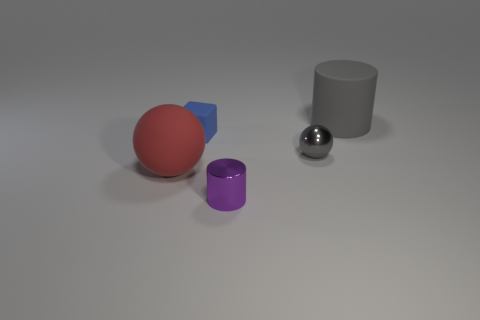What size is the red sphere that is made of the same material as the large gray thing?
Offer a terse response. Large. Are there more things than tiny green metallic cylinders?
Ensure brevity in your answer.  Yes. What is the material of the blue thing that is the same size as the gray sphere?
Ensure brevity in your answer.  Rubber. Does the cylinder on the right side of the purple metal cylinder have the same size as the small metallic cylinder?
Keep it short and to the point. No. How many blocks are either gray metal things or large gray rubber things?
Provide a succinct answer. 0. There is a big thing to the left of the metal sphere; what material is it?
Ensure brevity in your answer.  Rubber. Is the number of tiny metallic cylinders less than the number of large purple matte balls?
Your response must be concise. No. There is a thing that is both in front of the cube and on the left side of the purple metallic cylinder; what is its size?
Your answer should be very brief. Large. There is a shiny ball on the right side of the cylinder that is in front of the big matte object that is behind the gray metal object; what size is it?
Ensure brevity in your answer.  Small. How many other things are the same color as the large matte cylinder?
Provide a succinct answer. 1. 